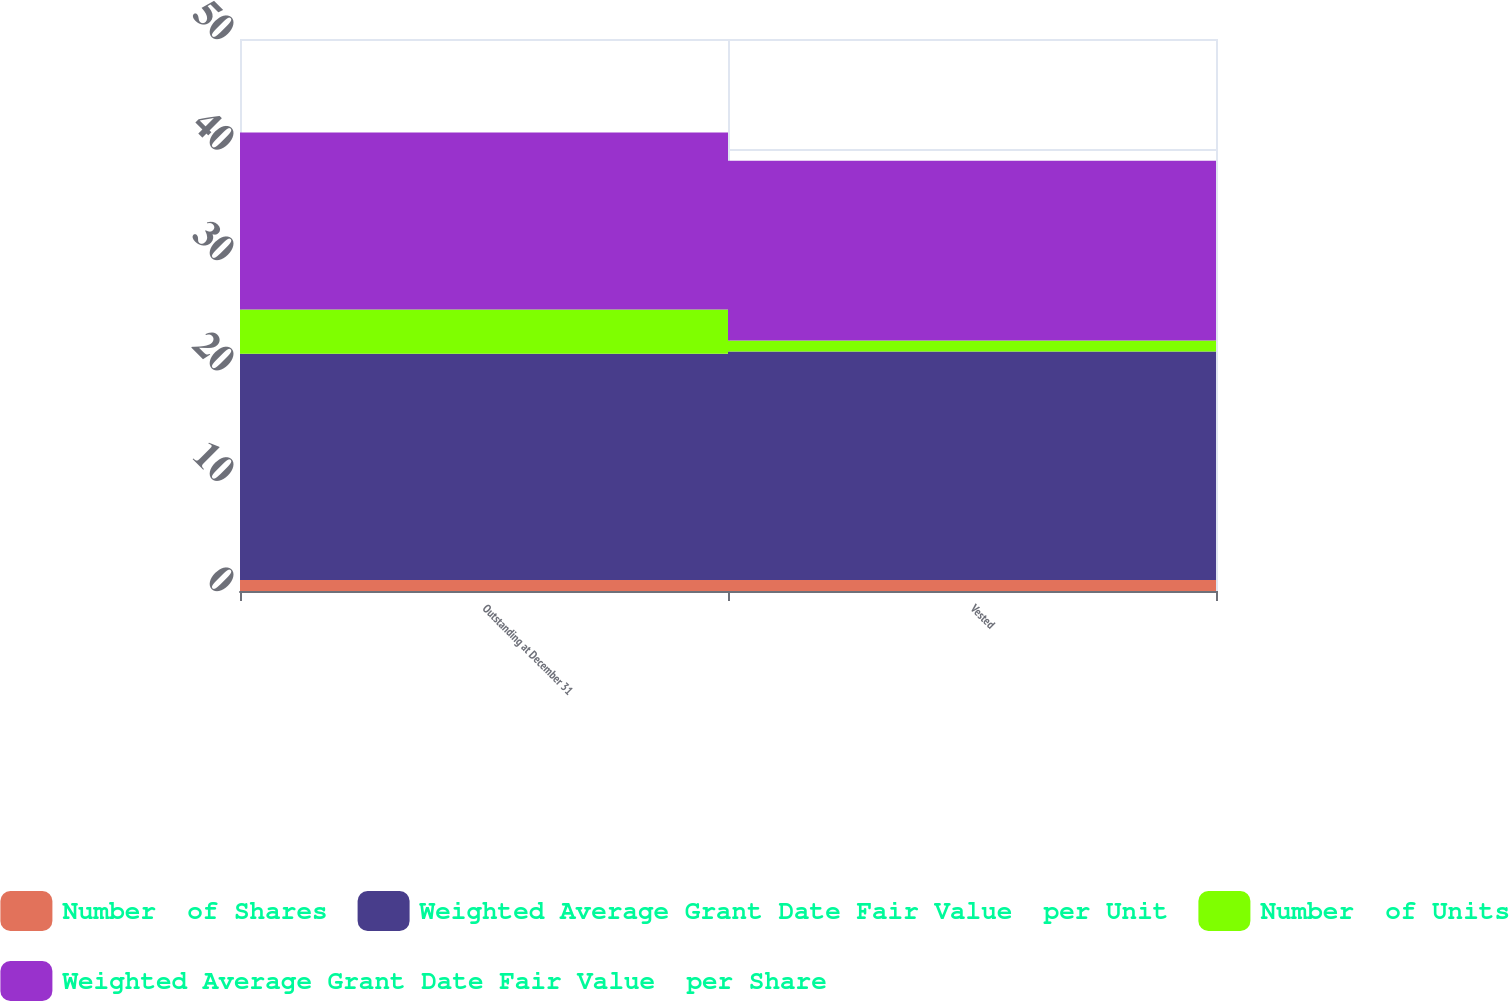Convert chart to OTSL. <chart><loc_0><loc_0><loc_500><loc_500><stacked_bar_chart><ecel><fcel>Outstanding at December 31<fcel>Vested<nl><fcel>Number  of Shares<fcel>1<fcel>1<nl><fcel>Weighted Average Grant Date Fair Value  per Unit<fcel>20.49<fcel>20.69<nl><fcel>Number  of Units<fcel>4<fcel>1<nl><fcel>Weighted Average Grant Date Fair Value  per Share<fcel>16.04<fcel>16.28<nl></chart> 